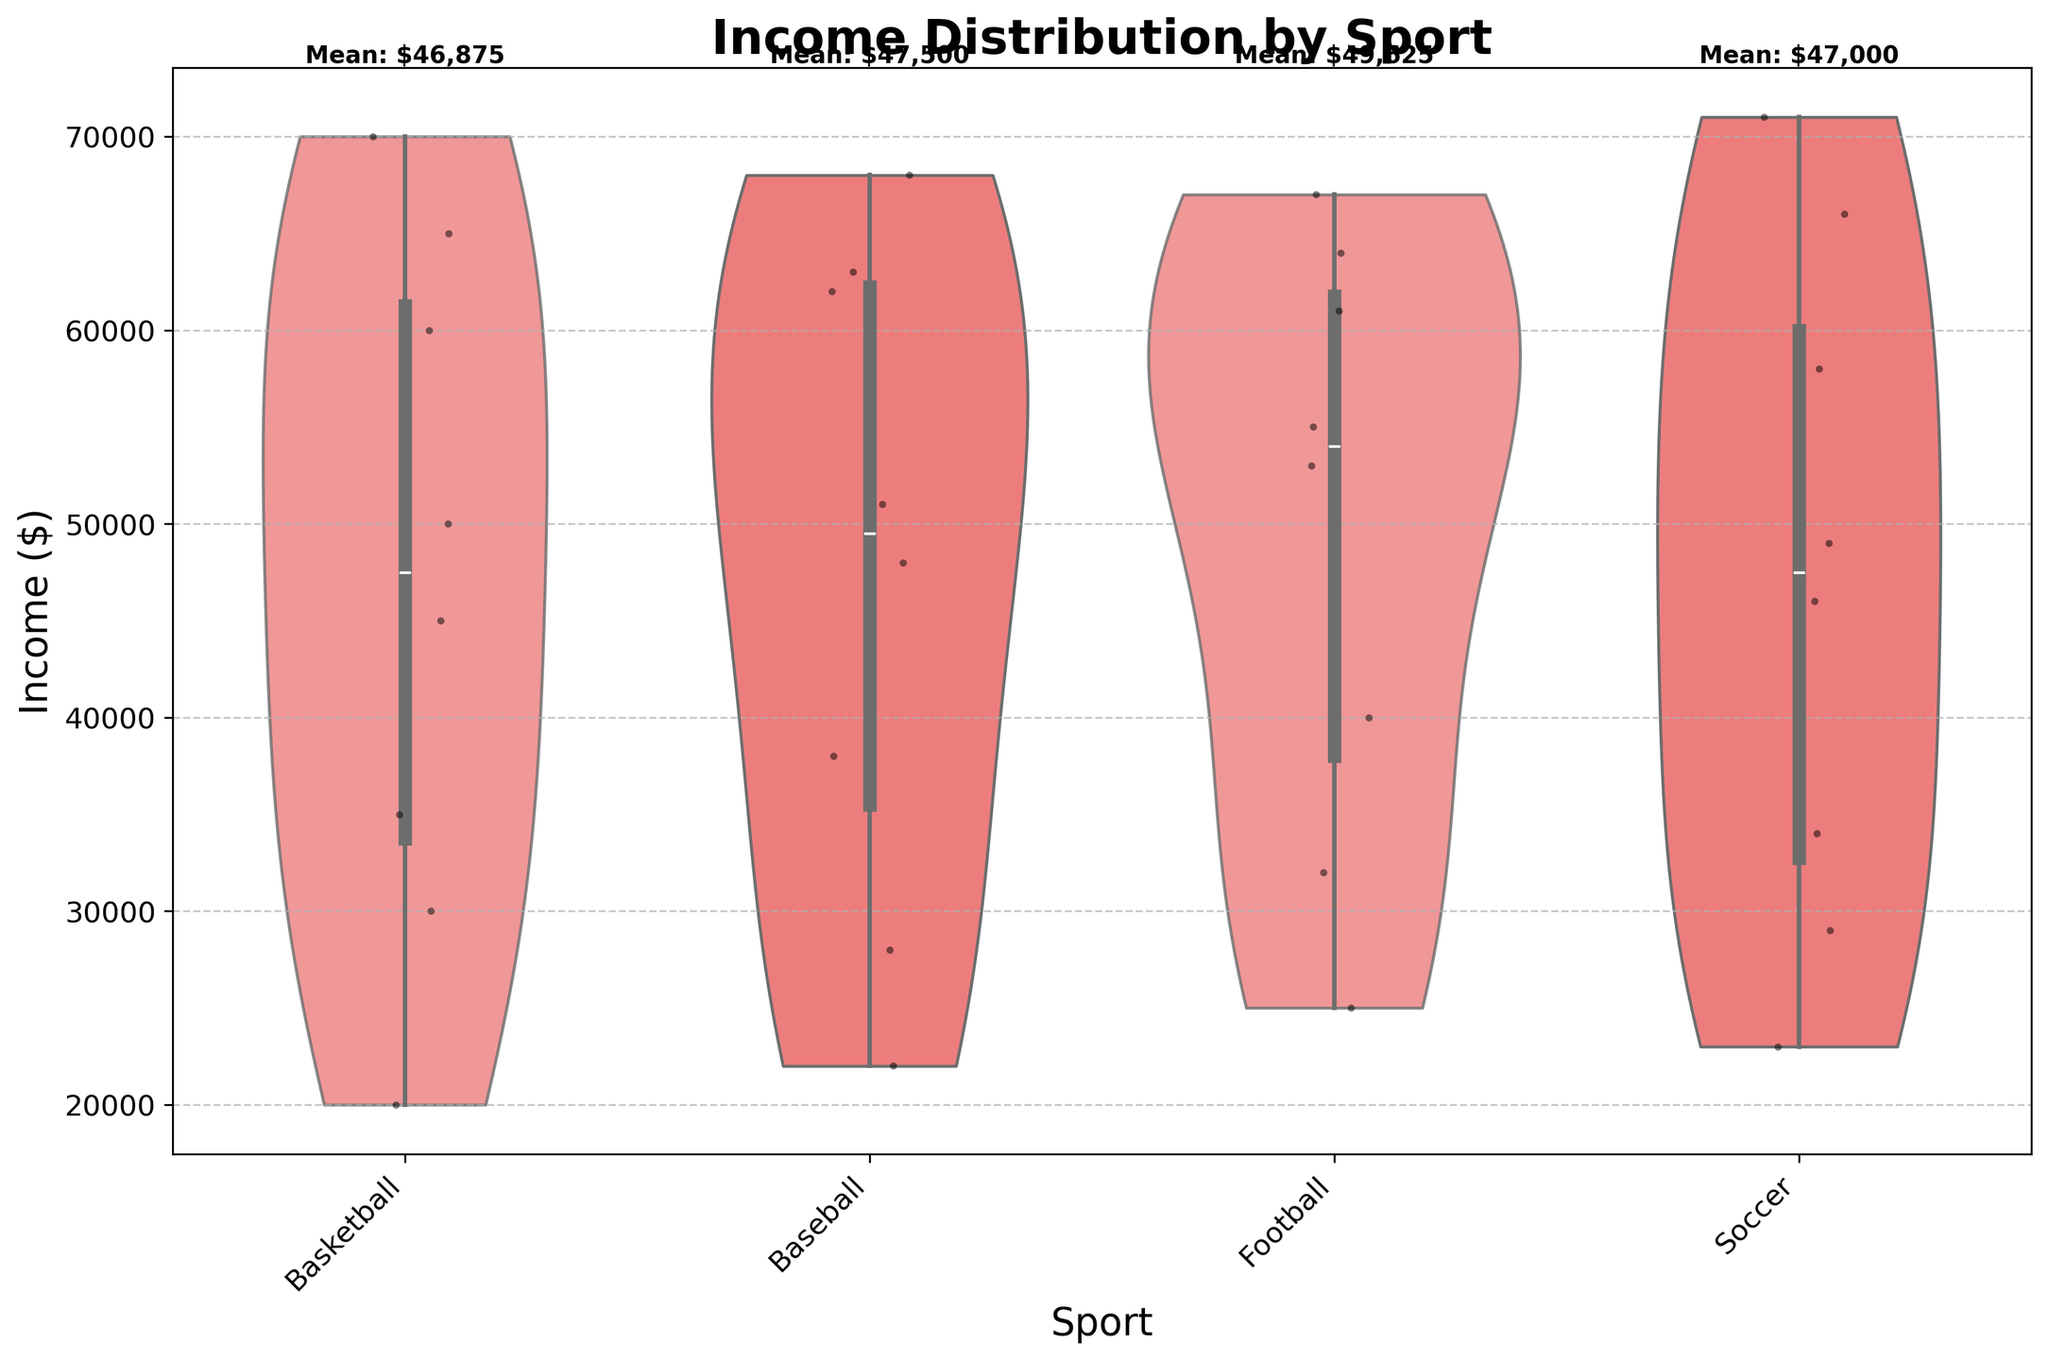What is the title of the figure? The title can be found at the top of the figure. Here, the title is clearly written as "Income Distribution by Sport."
Answer: Income Distribution by Sport Which sport has the highest mean income? The figure shows the mean income values above each sport category. By looking at the values, we can see that Soccer has the highest mean income.
Answer: Soccer What is the range of income in the Baseball category? To find the range, identify the lowest and highest points in the violin plot for Baseball. The lowest point is around $22,000, and the highest is close to $68,000. The range is $68,000 - $22,000 = $46,000.
Answer: $46,000 How do the income distributions of Basketball and Football compare? By examining the violin plots, we can see that both have similar distributions, but Football's upper range is slightly higher than Basketball's, and Basketball's lower range is slightly lower than Football's.
Answer: Football's upper range is slightly higher, and Basketball's lower range is slightly lower Which sport category shows the widest spread in income distribution? The spread can be identified by the width of the violin plot. Soccer shows the widest spread as it has a broader and more extensive distribution compared to other sports.
Answer: Soccer What is the mean income for the sport with the lowest identified mean income? Each mean income is labeled at the top of the plot. The sport with the lowest mean income is Basketball, with a mean income of $43,000.
Answer: $43,000 Are there any sports where the income distribution is highly concentrated within a narrow range? To determine this, look for the violin plots that are very narrow. Baseball and Football have relatively narrow distributions compared to others.
Answer: Baseball, Football Which sport has the least variance in income distribution, and how can you tell? Least variance is indicated by a narrow and concentrated violin plot. Football shows the least variance as its plot is narrower compared to other sports.
Answer: Football Are there any outliers in the Soccer income distribution? Outliers in a violin plot are usually represented by individual points far from the central bulge of the distribution. There are no clear outliers for Soccer in this figure.
Answer: No How does the income distribution of Soccer compare to that of Baseball in terms of variability? By comparing the violin plots, Baseball shows a narrower, more concentrated distribution, while Soccer displays a broader distribution, indicating more variability in Soccer incomes.
Answer: Soccer has more variability 